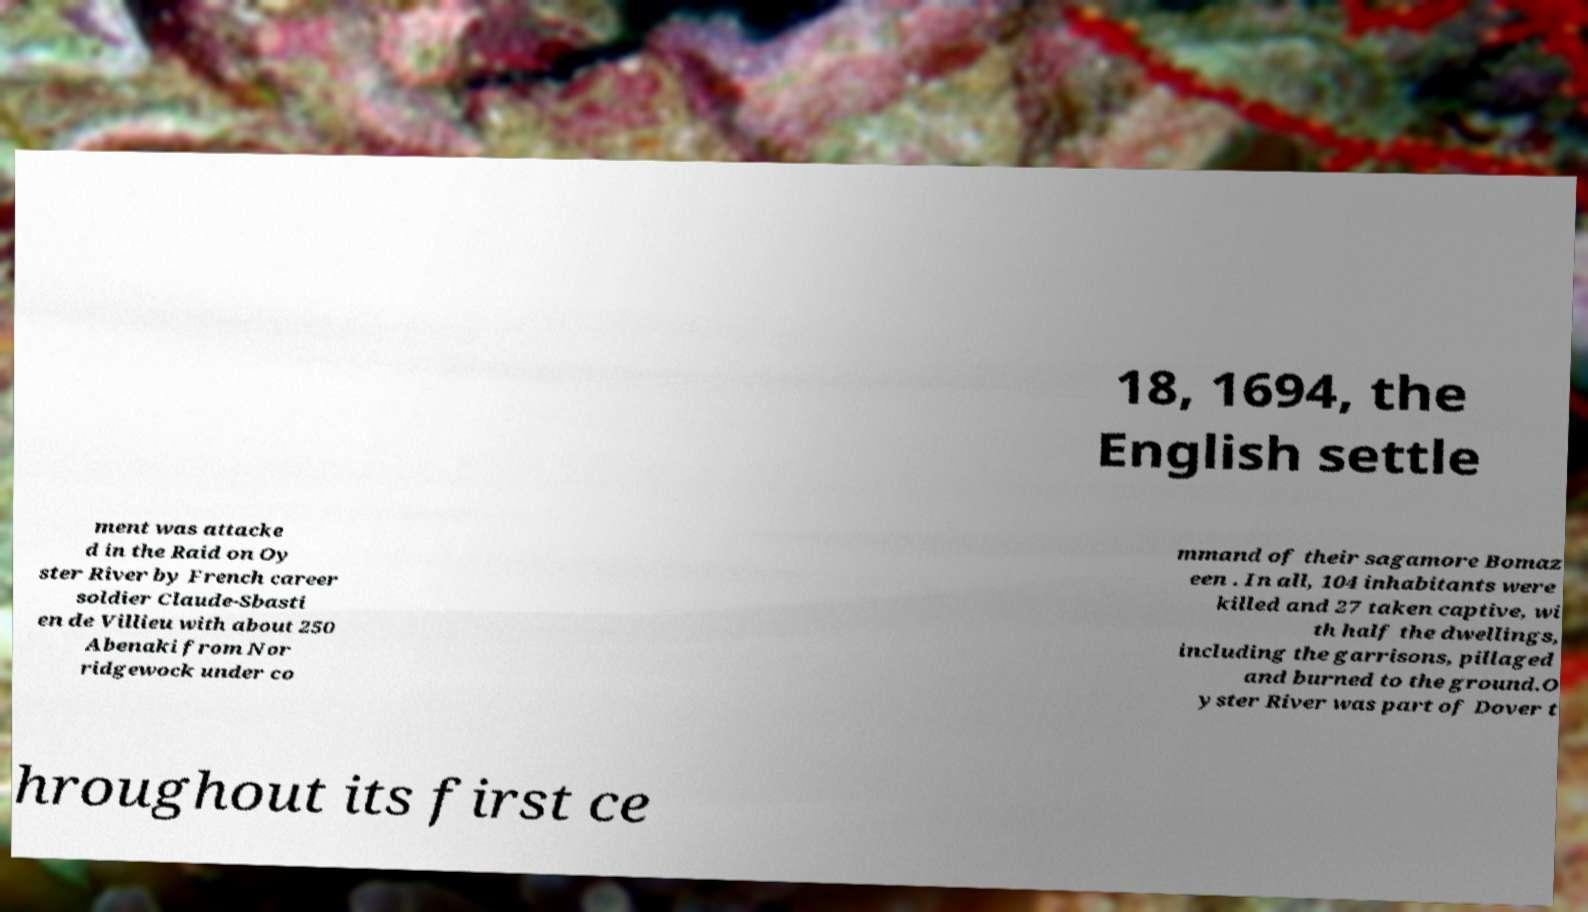Could you extract and type out the text from this image? 18, 1694, the English settle ment was attacke d in the Raid on Oy ster River by French career soldier Claude-Sbasti en de Villieu with about 250 Abenaki from Nor ridgewock under co mmand of their sagamore Bomaz een . In all, 104 inhabitants were killed and 27 taken captive, wi th half the dwellings, including the garrisons, pillaged and burned to the ground.O yster River was part of Dover t hroughout its first ce 